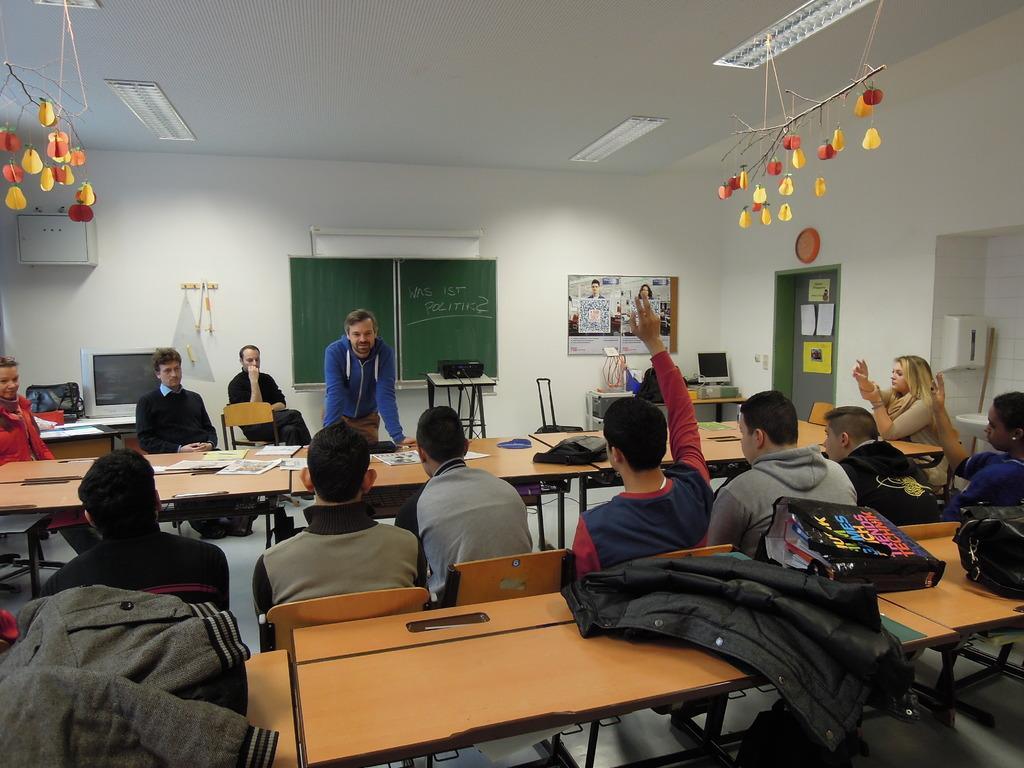Can you describe this image briefly? Here we can see a few people who are sitting on a chair and there are two persons who raise their hand. There is a person standing in the center and he is smiling. In the background we can see a board, a projector on the table and computer. 